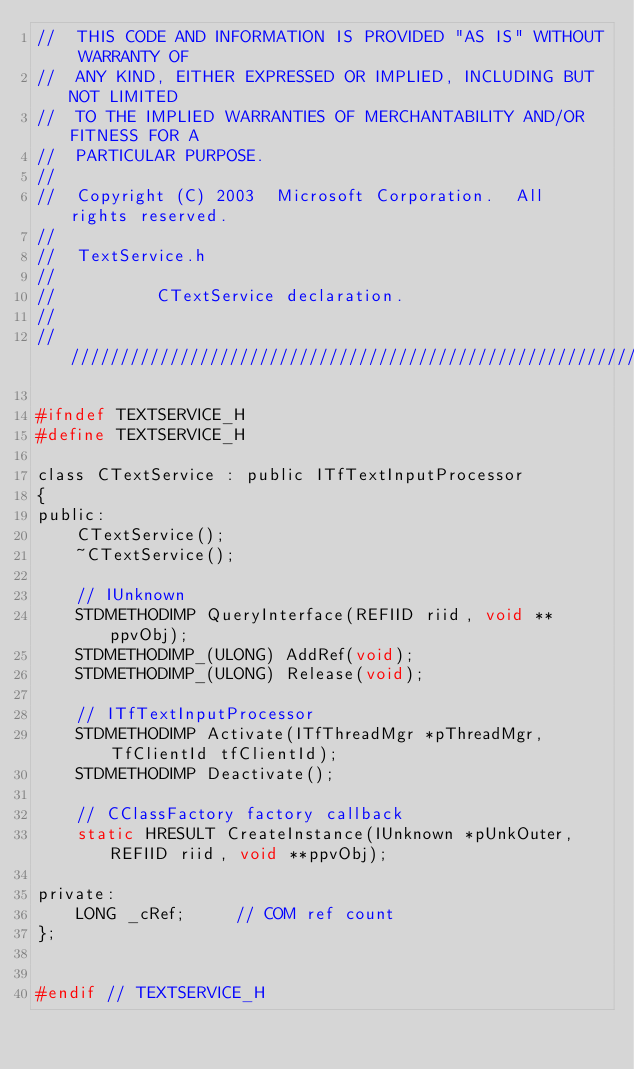<code> <loc_0><loc_0><loc_500><loc_500><_C_>//  THIS CODE AND INFORMATION IS PROVIDED "AS IS" WITHOUT WARRANTY OF
//  ANY KIND, EITHER EXPRESSED OR IMPLIED, INCLUDING BUT NOT LIMITED
//  TO THE IMPLIED WARRANTIES OF MERCHANTABILITY AND/OR FITNESS FOR A
//  PARTICULAR PURPOSE.
//
//  Copyright (C) 2003  Microsoft Corporation.  All rights reserved.
//
//  TextService.h
//
//          CTextService declaration.
//
//////////////////////////////////////////////////////////////////////

#ifndef TEXTSERVICE_H
#define TEXTSERVICE_H

class CTextService : public ITfTextInputProcessor
{
public:
    CTextService();
    ~CTextService();

    // IUnknown
    STDMETHODIMP QueryInterface(REFIID riid, void **ppvObj);
    STDMETHODIMP_(ULONG) AddRef(void);
    STDMETHODIMP_(ULONG) Release(void);

    // ITfTextInputProcessor
    STDMETHODIMP Activate(ITfThreadMgr *pThreadMgr, TfClientId tfClientId);
    STDMETHODIMP Deactivate();

    // CClassFactory factory callback
    static HRESULT CreateInstance(IUnknown *pUnkOuter, REFIID riid, void **ppvObj);

private:
    LONG _cRef;     // COM ref count
};


#endif // TEXTSERVICE_H
</code> 